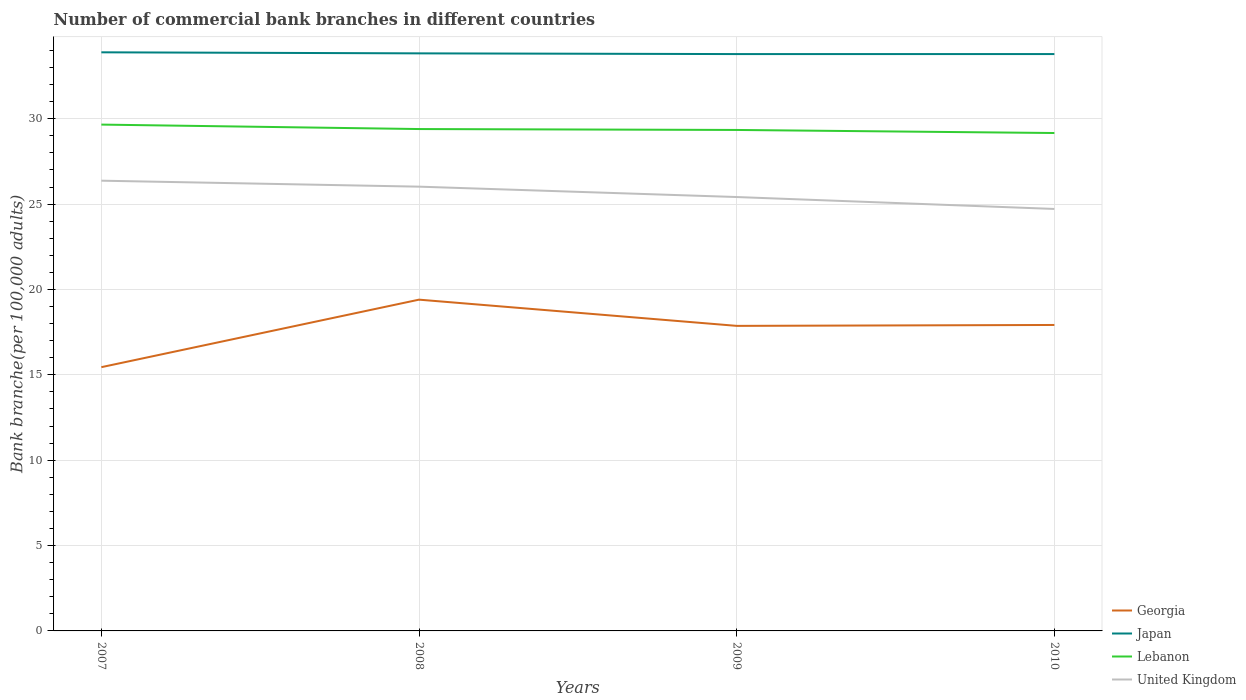Across all years, what is the maximum number of commercial bank branches in Lebanon?
Make the answer very short. 29.17. In which year was the number of commercial bank branches in Georgia maximum?
Keep it short and to the point. 2007. What is the total number of commercial bank branches in Japan in the graph?
Provide a succinct answer. 0.06. What is the difference between the highest and the second highest number of commercial bank branches in Georgia?
Ensure brevity in your answer.  3.95. How many years are there in the graph?
Make the answer very short. 4. What is the difference between two consecutive major ticks on the Y-axis?
Make the answer very short. 5. Does the graph contain grids?
Your answer should be very brief. Yes. How many legend labels are there?
Provide a succinct answer. 4. How are the legend labels stacked?
Keep it short and to the point. Vertical. What is the title of the graph?
Ensure brevity in your answer.  Number of commercial bank branches in different countries. Does "Lithuania" appear as one of the legend labels in the graph?
Provide a succinct answer. No. What is the label or title of the Y-axis?
Your answer should be very brief. Bank branche(per 100,0 adults). What is the Bank branche(per 100,000 adults) of Georgia in 2007?
Your response must be concise. 15.45. What is the Bank branche(per 100,000 adults) of Japan in 2007?
Make the answer very short. 33.89. What is the Bank branche(per 100,000 adults) of Lebanon in 2007?
Give a very brief answer. 29.66. What is the Bank branche(per 100,000 adults) of United Kingdom in 2007?
Offer a very short reply. 26.37. What is the Bank branche(per 100,000 adults) of Georgia in 2008?
Your answer should be compact. 19.4. What is the Bank branche(per 100,000 adults) of Japan in 2008?
Your answer should be compact. 33.83. What is the Bank branche(per 100,000 adults) of Lebanon in 2008?
Your answer should be compact. 29.4. What is the Bank branche(per 100,000 adults) in United Kingdom in 2008?
Offer a terse response. 26.02. What is the Bank branche(per 100,000 adults) of Georgia in 2009?
Make the answer very short. 17.87. What is the Bank branche(per 100,000 adults) of Japan in 2009?
Offer a terse response. 33.79. What is the Bank branche(per 100,000 adults) in Lebanon in 2009?
Offer a very short reply. 29.35. What is the Bank branche(per 100,000 adults) of United Kingdom in 2009?
Make the answer very short. 25.42. What is the Bank branche(per 100,000 adults) in Georgia in 2010?
Make the answer very short. 17.92. What is the Bank branche(per 100,000 adults) of Japan in 2010?
Your response must be concise. 33.79. What is the Bank branche(per 100,000 adults) of Lebanon in 2010?
Offer a very short reply. 29.17. What is the Bank branche(per 100,000 adults) of United Kingdom in 2010?
Your response must be concise. 24.72. Across all years, what is the maximum Bank branche(per 100,000 adults) of Georgia?
Ensure brevity in your answer.  19.4. Across all years, what is the maximum Bank branche(per 100,000 adults) in Japan?
Offer a very short reply. 33.89. Across all years, what is the maximum Bank branche(per 100,000 adults) of Lebanon?
Provide a short and direct response. 29.66. Across all years, what is the maximum Bank branche(per 100,000 adults) of United Kingdom?
Provide a short and direct response. 26.37. Across all years, what is the minimum Bank branche(per 100,000 adults) of Georgia?
Your answer should be very brief. 15.45. Across all years, what is the minimum Bank branche(per 100,000 adults) of Japan?
Make the answer very short. 33.79. Across all years, what is the minimum Bank branche(per 100,000 adults) of Lebanon?
Make the answer very short. 29.17. Across all years, what is the minimum Bank branche(per 100,000 adults) in United Kingdom?
Provide a short and direct response. 24.72. What is the total Bank branche(per 100,000 adults) in Georgia in the graph?
Provide a short and direct response. 70.65. What is the total Bank branche(per 100,000 adults) in Japan in the graph?
Provide a short and direct response. 135.31. What is the total Bank branche(per 100,000 adults) in Lebanon in the graph?
Offer a very short reply. 117.57. What is the total Bank branche(per 100,000 adults) in United Kingdom in the graph?
Ensure brevity in your answer.  102.53. What is the difference between the Bank branche(per 100,000 adults) in Georgia in 2007 and that in 2008?
Your answer should be very brief. -3.95. What is the difference between the Bank branche(per 100,000 adults) of Japan in 2007 and that in 2008?
Make the answer very short. 0.06. What is the difference between the Bank branche(per 100,000 adults) in Lebanon in 2007 and that in 2008?
Give a very brief answer. 0.26. What is the difference between the Bank branche(per 100,000 adults) in United Kingdom in 2007 and that in 2008?
Provide a succinct answer. 0.35. What is the difference between the Bank branche(per 100,000 adults) of Georgia in 2007 and that in 2009?
Give a very brief answer. -2.42. What is the difference between the Bank branche(per 100,000 adults) in Japan in 2007 and that in 2009?
Offer a very short reply. 0.1. What is the difference between the Bank branche(per 100,000 adults) of Lebanon in 2007 and that in 2009?
Your response must be concise. 0.31. What is the difference between the Bank branche(per 100,000 adults) of United Kingdom in 2007 and that in 2009?
Keep it short and to the point. 0.96. What is the difference between the Bank branche(per 100,000 adults) of Georgia in 2007 and that in 2010?
Provide a succinct answer. -2.47. What is the difference between the Bank branche(per 100,000 adults) in Japan in 2007 and that in 2010?
Your answer should be compact. 0.1. What is the difference between the Bank branche(per 100,000 adults) of Lebanon in 2007 and that in 2010?
Make the answer very short. 0.49. What is the difference between the Bank branche(per 100,000 adults) in United Kingdom in 2007 and that in 2010?
Your response must be concise. 1.66. What is the difference between the Bank branche(per 100,000 adults) of Georgia in 2008 and that in 2009?
Provide a short and direct response. 1.54. What is the difference between the Bank branche(per 100,000 adults) in Japan in 2008 and that in 2009?
Your response must be concise. 0.04. What is the difference between the Bank branche(per 100,000 adults) of Lebanon in 2008 and that in 2009?
Give a very brief answer. 0.05. What is the difference between the Bank branche(per 100,000 adults) of United Kingdom in 2008 and that in 2009?
Your answer should be compact. 0.61. What is the difference between the Bank branche(per 100,000 adults) in Georgia in 2008 and that in 2010?
Make the answer very short. 1.48. What is the difference between the Bank branche(per 100,000 adults) of Japan in 2008 and that in 2010?
Give a very brief answer. 0.04. What is the difference between the Bank branche(per 100,000 adults) in Lebanon in 2008 and that in 2010?
Provide a succinct answer. 0.23. What is the difference between the Bank branche(per 100,000 adults) of United Kingdom in 2008 and that in 2010?
Offer a very short reply. 1.31. What is the difference between the Bank branche(per 100,000 adults) in Georgia in 2009 and that in 2010?
Keep it short and to the point. -0.05. What is the difference between the Bank branche(per 100,000 adults) of Japan in 2009 and that in 2010?
Keep it short and to the point. -0. What is the difference between the Bank branche(per 100,000 adults) of Lebanon in 2009 and that in 2010?
Your response must be concise. 0.18. What is the difference between the Bank branche(per 100,000 adults) of United Kingdom in 2009 and that in 2010?
Your answer should be very brief. 0.7. What is the difference between the Bank branche(per 100,000 adults) in Georgia in 2007 and the Bank branche(per 100,000 adults) in Japan in 2008?
Keep it short and to the point. -18.38. What is the difference between the Bank branche(per 100,000 adults) in Georgia in 2007 and the Bank branche(per 100,000 adults) in Lebanon in 2008?
Your response must be concise. -13.95. What is the difference between the Bank branche(per 100,000 adults) of Georgia in 2007 and the Bank branche(per 100,000 adults) of United Kingdom in 2008?
Keep it short and to the point. -10.57. What is the difference between the Bank branche(per 100,000 adults) of Japan in 2007 and the Bank branche(per 100,000 adults) of Lebanon in 2008?
Make the answer very short. 4.49. What is the difference between the Bank branche(per 100,000 adults) in Japan in 2007 and the Bank branche(per 100,000 adults) in United Kingdom in 2008?
Your answer should be compact. 7.87. What is the difference between the Bank branche(per 100,000 adults) in Lebanon in 2007 and the Bank branche(per 100,000 adults) in United Kingdom in 2008?
Give a very brief answer. 3.64. What is the difference between the Bank branche(per 100,000 adults) in Georgia in 2007 and the Bank branche(per 100,000 adults) in Japan in 2009?
Your answer should be very brief. -18.34. What is the difference between the Bank branche(per 100,000 adults) in Georgia in 2007 and the Bank branche(per 100,000 adults) in Lebanon in 2009?
Make the answer very short. -13.9. What is the difference between the Bank branche(per 100,000 adults) of Georgia in 2007 and the Bank branche(per 100,000 adults) of United Kingdom in 2009?
Your answer should be very brief. -9.97. What is the difference between the Bank branche(per 100,000 adults) of Japan in 2007 and the Bank branche(per 100,000 adults) of Lebanon in 2009?
Offer a terse response. 4.55. What is the difference between the Bank branche(per 100,000 adults) in Japan in 2007 and the Bank branche(per 100,000 adults) in United Kingdom in 2009?
Your answer should be very brief. 8.48. What is the difference between the Bank branche(per 100,000 adults) of Lebanon in 2007 and the Bank branche(per 100,000 adults) of United Kingdom in 2009?
Your response must be concise. 4.24. What is the difference between the Bank branche(per 100,000 adults) of Georgia in 2007 and the Bank branche(per 100,000 adults) of Japan in 2010?
Offer a terse response. -18.34. What is the difference between the Bank branche(per 100,000 adults) in Georgia in 2007 and the Bank branche(per 100,000 adults) in Lebanon in 2010?
Keep it short and to the point. -13.72. What is the difference between the Bank branche(per 100,000 adults) of Georgia in 2007 and the Bank branche(per 100,000 adults) of United Kingdom in 2010?
Provide a short and direct response. -9.27. What is the difference between the Bank branche(per 100,000 adults) of Japan in 2007 and the Bank branche(per 100,000 adults) of Lebanon in 2010?
Ensure brevity in your answer.  4.73. What is the difference between the Bank branche(per 100,000 adults) of Japan in 2007 and the Bank branche(per 100,000 adults) of United Kingdom in 2010?
Give a very brief answer. 9.18. What is the difference between the Bank branche(per 100,000 adults) of Lebanon in 2007 and the Bank branche(per 100,000 adults) of United Kingdom in 2010?
Your answer should be compact. 4.94. What is the difference between the Bank branche(per 100,000 adults) of Georgia in 2008 and the Bank branche(per 100,000 adults) of Japan in 2009?
Your answer should be compact. -14.39. What is the difference between the Bank branche(per 100,000 adults) in Georgia in 2008 and the Bank branche(per 100,000 adults) in Lebanon in 2009?
Your answer should be very brief. -9.94. What is the difference between the Bank branche(per 100,000 adults) in Georgia in 2008 and the Bank branche(per 100,000 adults) in United Kingdom in 2009?
Your answer should be very brief. -6.01. What is the difference between the Bank branche(per 100,000 adults) in Japan in 2008 and the Bank branche(per 100,000 adults) in Lebanon in 2009?
Offer a very short reply. 4.49. What is the difference between the Bank branche(per 100,000 adults) of Japan in 2008 and the Bank branche(per 100,000 adults) of United Kingdom in 2009?
Your response must be concise. 8.42. What is the difference between the Bank branche(per 100,000 adults) in Lebanon in 2008 and the Bank branche(per 100,000 adults) in United Kingdom in 2009?
Your answer should be compact. 3.98. What is the difference between the Bank branche(per 100,000 adults) of Georgia in 2008 and the Bank branche(per 100,000 adults) of Japan in 2010?
Offer a terse response. -14.39. What is the difference between the Bank branche(per 100,000 adults) in Georgia in 2008 and the Bank branche(per 100,000 adults) in Lebanon in 2010?
Offer a very short reply. -9.76. What is the difference between the Bank branche(per 100,000 adults) of Georgia in 2008 and the Bank branche(per 100,000 adults) of United Kingdom in 2010?
Offer a terse response. -5.31. What is the difference between the Bank branche(per 100,000 adults) in Japan in 2008 and the Bank branche(per 100,000 adults) in Lebanon in 2010?
Your answer should be compact. 4.67. What is the difference between the Bank branche(per 100,000 adults) of Japan in 2008 and the Bank branche(per 100,000 adults) of United Kingdom in 2010?
Make the answer very short. 9.11. What is the difference between the Bank branche(per 100,000 adults) of Lebanon in 2008 and the Bank branche(per 100,000 adults) of United Kingdom in 2010?
Your answer should be compact. 4.68. What is the difference between the Bank branche(per 100,000 adults) of Georgia in 2009 and the Bank branche(per 100,000 adults) of Japan in 2010?
Offer a terse response. -15.92. What is the difference between the Bank branche(per 100,000 adults) of Georgia in 2009 and the Bank branche(per 100,000 adults) of Lebanon in 2010?
Provide a short and direct response. -11.3. What is the difference between the Bank branche(per 100,000 adults) of Georgia in 2009 and the Bank branche(per 100,000 adults) of United Kingdom in 2010?
Ensure brevity in your answer.  -6.85. What is the difference between the Bank branche(per 100,000 adults) of Japan in 2009 and the Bank branche(per 100,000 adults) of Lebanon in 2010?
Keep it short and to the point. 4.62. What is the difference between the Bank branche(per 100,000 adults) of Japan in 2009 and the Bank branche(per 100,000 adults) of United Kingdom in 2010?
Your answer should be compact. 9.07. What is the difference between the Bank branche(per 100,000 adults) of Lebanon in 2009 and the Bank branche(per 100,000 adults) of United Kingdom in 2010?
Your response must be concise. 4.63. What is the average Bank branche(per 100,000 adults) in Georgia per year?
Offer a terse response. 17.66. What is the average Bank branche(per 100,000 adults) in Japan per year?
Keep it short and to the point. 33.83. What is the average Bank branche(per 100,000 adults) of Lebanon per year?
Give a very brief answer. 29.39. What is the average Bank branche(per 100,000 adults) in United Kingdom per year?
Offer a very short reply. 25.63. In the year 2007, what is the difference between the Bank branche(per 100,000 adults) in Georgia and Bank branche(per 100,000 adults) in Japan?
Give a very brief answer. -18.44. In the year 2007, what is the difference between the Bank branche(per 100,000 adults) of Georgia and Bank branche(per 100,000 adults) of Lebanon?
Ensure brevity in your answer.  -14.21. In the year 2007, what is the difference between the Bank branche(per 100,000 adults) of Georgia and Bank branche(per 100,000 adults) of United Kingdom?
Ensure brevity in your answer.  -10.92. In the year 2007, what is the difference between the Bank branche(per 100,000 adults) in Japan and Bank branche(per 100,000 adults) in Lebanon?
Ensure brevity in your answer.  4.23. In the year 2007, what is the difference between the Bank branche(per 100,000 adults) in Japan and Bank branche(per 100,000 adults) in United Kingdom?
Offer a very short reply. 7.52. In the year 2007, what is the difference between the Bank branche(per 100,000 adults) in Lebanon and Bank branche(per 100,000 adults) in United Kingdom?
Your answer should be compact. 3.29. In the year 2008, what is the difference between the Bank branche(per 100,000 adults) in Georgia and Bank branche(per 100,000 adults) in Japan?
Ensure brevity in your answer.  -14.43. In the year 2008, what is the difference between the Bank branche(per 100,000 adults) in Georgia and Bank branche(per 100,000 adults) in Lebanon?
Your response must be concise. -9.99. In the year 2008, what is the difference between the Bank branche(per 100,000 adults) in Georgia and Bank branche(per 100,000 adults) in United Kingdom?
Your response must be concise. -6.62. In the year 2008, what is the difference between the Bank branche(per 100,000 adults) of Japan and Bank branche(per 100,000 adults) of Lebanon?
Ensure brevity in your answer.  4.43. In the year 2008, what is the difference between the Bank branche(per 100,000 adults) in Japan and Bank branche(per 100,000 adults) in United Kingdom?
Offer a terse response. 7.81. In the year 2008, what is the difference between the Bank branche(per 100,000 adults) of Lebanon and Bank branche(per 100,000 adults) of United Kingdom?
Provide a succinct answer. 3.37. In the year 2009, what is the difference between the Bank branche(per 100,000 adults) in Georgia and Bank branche(per 100,000 adults) in Japan?
Provide a succinct answer. -15.92. In the year 2009, what is the difference between the Bank branche(per 100,000 adults) in Georgia and Bank branche(per 100,000 adults) in Lebanon?
Your answer should be very brief. -11.48. In the year 2009, what is the difference between the Bank branche(per 100,000 adults) in Georgia and Bank branche(per 100,000 adults) in United Kingdom?
Your response must be concise. -7.55. In the year 2009, what is the difference between the Bank branche(per 100,000 adults) in Japan and Bank branche(per 100,000 adults) in Lebanon?
Provide a short and direct response. 4.45. In the year 2009, what is the difference between the Bank branche(per 100,000 adults) of Japan and Bank branche(per 100,000 adults) of United Kingdom?
Ensure brevity in your answer.  8.37. In the year 2009, what is the difference between the Bank branche(per 100,000 adults) in Lebanon and Bank branche(per 100,000 adults) in United Kingdom?
Keep it short and to the point. 3.93. In the year 2010, what is the difference between the Bank branche(per 100,000 adults) of Georgia and Bank branche(per 100,000 adults) of Japan?
Offer a very short reply. -15.87. In the year 2010, what is the difference between the Bank branche(per 100,000 adults) of Georgia and Bank branche(per 100,000 adults) of Lebanon?
Keep it short and to the point. -11.24. In the year 2010, what is the difference between the Bank branche(per 100,000 adults) of Georgia and Bank branche(per 100,000 adults) of United Kingdom?
Ensure brevity in your answer.  -6.8. In the year 2010, what is the difference between the Bank branche(per 100,000 adults) of Japan and Bank branche(per 100,000 adults) of Lebanon?
Your answer should be compact. 4.63. In the year 2010, what is the difference between the Bank branche(per 100,000 adults) in Japan and Bank branche(per 100,000 adults) in United Kingdom?
Provide a succinct answer. 9.07. In the year 2010, what is the difference between the Bank branche(per 100,000 adults) of Lebanon and Bank branche(per 100,000 adults) of United Kingdom?
Provide a succinct answer. 4.45. What is the ratio of the Bank branche(per 100,000 adults) of Georgia in 2007 to that in 2008?
Provide a succinct answer. 0.8. What is the ratio of the Bank branche(per 100,000 adults) in Lebanon in 2007 to that in 2008?
Offer a very short reply. 1.01. What is the ratio of the Bank branche(per 100,000 adults) in United Kingdom in 2007 to that in 2008?
Ensure brevity in your answer.  1.01. What is the ratio of the Bank branche(per 100,000 adults) of Georgia in 2007 to that in 2009?
Your response must be concise. 0.86. What is the ratio of the Bank branche(per 100,000 adults) of Japan in 2007 to that in 2009?
Your answer should be compact. 1. What is the ratio of the Bank branche(per 100,000 adults) of Lebanon in 2007 to that in 2009?
Keep it short and to the point. 1.01. What is the ratio of the Bank branche(per 100,000 adults) in United Kingdom in 2007 to that in 2009?
Your answer should be very brief. 1.04. What is the ratio of the Bank branche(per 100,000 adults) in Georgia in 2007 to that in 2010?
Keep it short and to the point. 0.86. What is the ratio of the Bank branche(per 100,000 adults) of Lebanon in 2007 to that in 2010?
Your answer should be very brief. 1.02. What is the ratio of the Bank branche(per 100,000 adults) of United Kingdom in 2007 to that in 2010?
Make the answer very short. 1.07. What is the ratio of the Bank branche(per 100,000 adults) of Georgia in 2008 to that in 2009?
Make the answer very short. 1.09. What is the ratio of the Bank branche(per 100,000 adults) of Japan in 2008 to that in 2009?
Your answer should be compact. 1. What is the ratio of the Bank branche(per 100,000 adults) of United Kingdom in 2008 to that in 2009?
Offer a terse response. 1.02. What is the ratio of the Bank branche(per 100,000 adults) in Georgia in 2008 to that in 2010?
Offer a very short reply. 1.08. What is the ratio of the Bank branche(per 100,000 adults) in United Kingdom in 2008 to that in 2010?
Your answer should be compact. 1.05. What is the ratio of the Bank branche(per 100,000 adults) in Lebanon in 2009 to that in 2010?
Your answer should be very brief. 1.01. What is the ratio of the Bank branche(per 100,000 adults) of United Kingdom in 2009 to that in 2010?
Offer a terse response. 1.03. What is the difference between the highest and the second highest Bank branche(per 100,000 adults) of Georgia?
Give a very brief answer. 1.48. What is the difference between the highest and the second highest Bank branche(per 100,000 adults) in Japan?
Offer a very short reply. 0.06. What is the difference between the highest and the second highest Bank branche(per 100,000 adults) of Lebanon?
Keep it short and to the point. 0.26. What is the difference between the highest and the second highest Bank branche(per 100,000 adults) in United Kingdom?
Give a very brief answer. 0.35. What is the difference between the highest and the lowest Bank branche(per 100,000 adults) of Georgia?
Provide a succinct answer. 3.95. What is the difference between the highest and the lowest Bank branche(per 100,000 adults) in Japan?
Make the answer very short. 0.1. What is the difference between the highest and the lowest Bank branche(per 100,000 adults) of Lebanon?
Ensure brevity in your answer.  0.49. What is the difference between the highest and the lowest Bank branche(per 100,000 adults) in United Kingdom?
Offer a terse response. 1.66. 